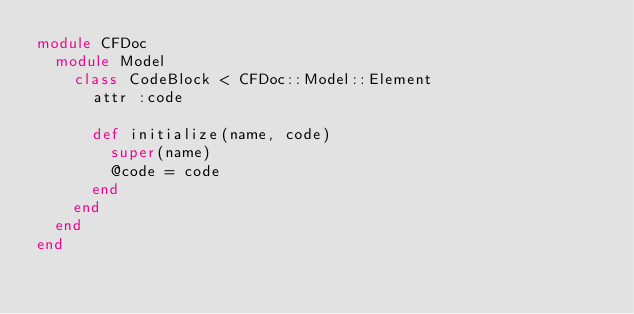Convert code to text. <code><loc_0><loc_0><loc_500><loc_500><_Ruby_>module CFDoc
  module Model
    class CodeBlock < CFDoc::Model::Element
      attr :code

      def initialize(name, code)
        super(name)
        @code = code
      end
    end
  end
end
</code> 